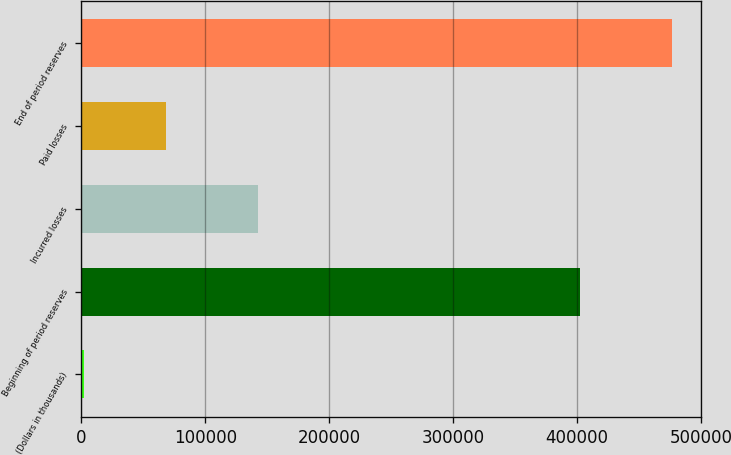Convert chart to OTSL. <chart><loc_0><loc_0><loc_500><loc_500><bar_chart><fcel>(Dollars in thousands)<fcel>Beginning of period reserves<fcel>Incurred losses<fcel>Paid losses<fcel>End of period reserves<nl><fcel>2014<fcel>402461<fcel>142233<fcel>68489<fcel>476205<nl></chart> 